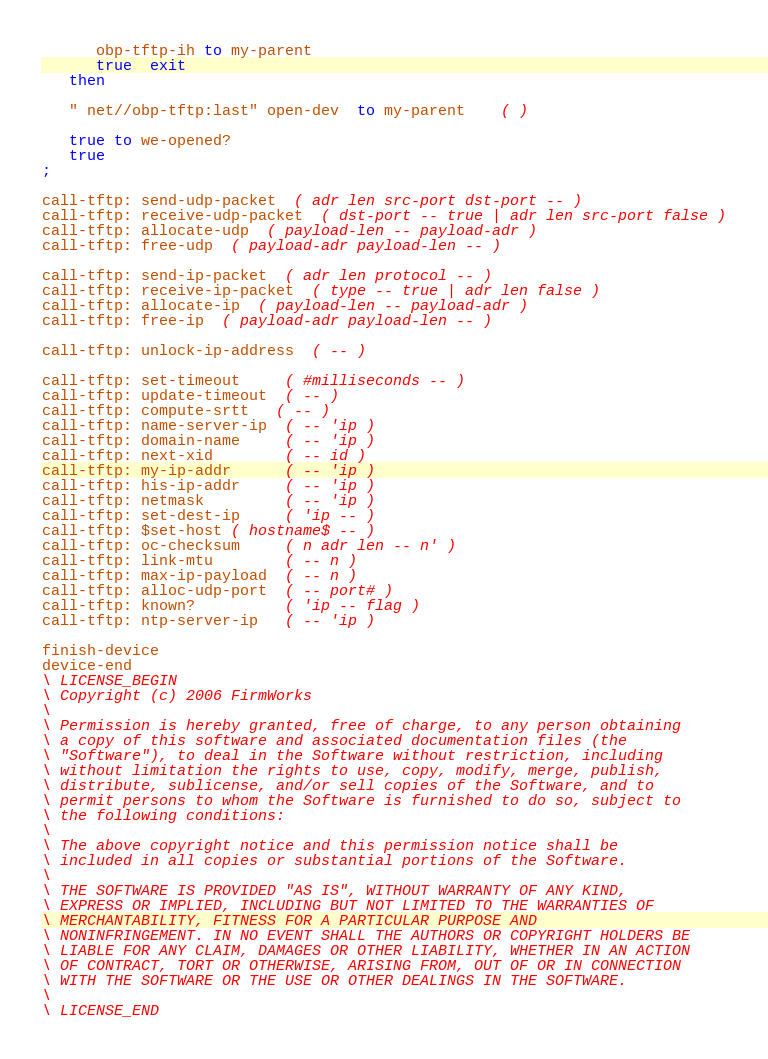<code> <loc_0><loc_0><loc_500><loc_500><_Forth_>      obp-tftp-ih to my-parent
      true  exit
   then

   " net//obp-tftp:last" open-dev  to my-parent    ( )

   true to we-opened?
   true
;

call-tftp: send-udp-packet  ( adr len src-port dst-port -- )
call-tftp: receive-udp-packet  ( dst-port -- true | adr len src-port false )
call-tftp: allocate-udp  ( payload-len -- payload-adr )
call-tftp: free-udp  ( payload-adr payload-len -- )

call-tftp: send-ip-packet  ( adr len protocol -- )
call-tftp: receive-ip-packet  ( type -- true | adr len false )
call-tftp: allocate-ip  ( payload-len -- payload-adr )
call-tftp: free-ip  ( payload-adr payload-len -- )

call-tftp: unlock-ip-address  ( -- )

call-tftp: set-timeout     ( #milliseconds -- )
call-tftp: update-timeout  ( -- )
call-tftp: compute-srtt   ( -- )
call-tftp: name-server-ip  ( -- 'ip )
call-tftp: domain-name     ( -- 'ip )
call-tftp: next-xid        ( -- id )
call-tftp: my-ip-addr      ( -- 'ip )
call-tftp: his-ip-addr     ( -- 'ip )
call-tftp: netmask         ( -- 'ip )
call-tftp: set-dest-ip     ( 'ip -- )
call-tftp: $set-host ( hostname$ -- )
call-tftp: oc-checksum     ( n adr len -- n' )
call-tftp: link-mtu        ( -- n )
call-tftp: max-ip-payload  ( -- n )
call-tftp: alloc-udp-port  ( -- port# )
call-tftp: known?          ( 'ip -- flag )
call-tftp: ntp-server-ip   ( -- 'ip )

finish-device
device-end
\ LICENSE_BEGIN
\ Copyright (c) 2006 FirmWorks
\ 
\ Permission is hereby granted, free of charge, to any person obtaining
\ a copy of this software and associated documentation files (the
\ "Software"), to deal in the Software without restriction, including
\ without limitation the rights to use, copy, modify, merge, publish,
\ distribute, sublicense, and/or sell copies of the Software, and to
\ permit persons to whom the Software is furnished to do so, subject to
\ the following conditions:
\ 
\ The above copyright notice and this permission notice shall be
\ included in all copies or substantial portions of the Software.
\ 
\ THE SOFTWARE IS PROVIDED "AS IS", WITHOUT WARRANTY OF ANY KIND,
\ EXPRESS OR IMPLIED, INCLUDING BUT NOT LIMITED TO THE WARRANTIES OF
\ MERCHANTABILITY, FITNESS FOR A PARTICULAR PURPOSE AND
\ NONINFRINGEMENT. IN NO EVENT SHALL THE AUTHORS OR COPYRIGHT HOLDERS BE
\ LIABLE FOR ANY CLAIM, DAMAGES OR OTHER LIABILITY, WHETHER IN AN ACTION
\ OF CONTRACT, TORT OR OTHERWISE, ARISING FROM, OUT OF OR IN CONNECTION
\ WITH THE SOFTWARE OR THE USE OR OTHER DEALINGS IN THE SOFTWARE.
\
\ LICENSE_END
</code> 